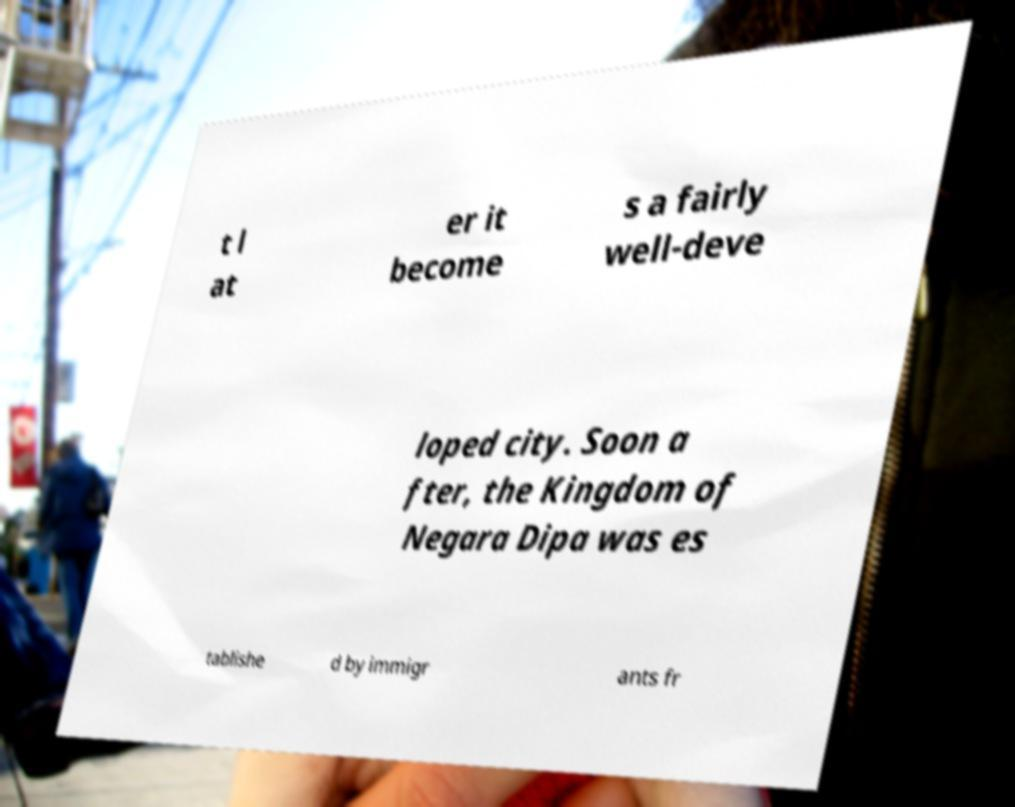Could you extract and type out the text from this image? t l at er it become s a fairly well-deve loped city. Soon a fter, the Kingdom of Negara Dipa was es tablishe d by immigr ants fr 